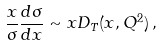Convert formula to latex. <formula><loc_0><loc_0><loc_500><loc_500>\frac { x } { \sigma } \frac { d \sigma } { d x } \sim x D _ { T } ( x , Q ^ { 2 } ) \, ,</formula> 